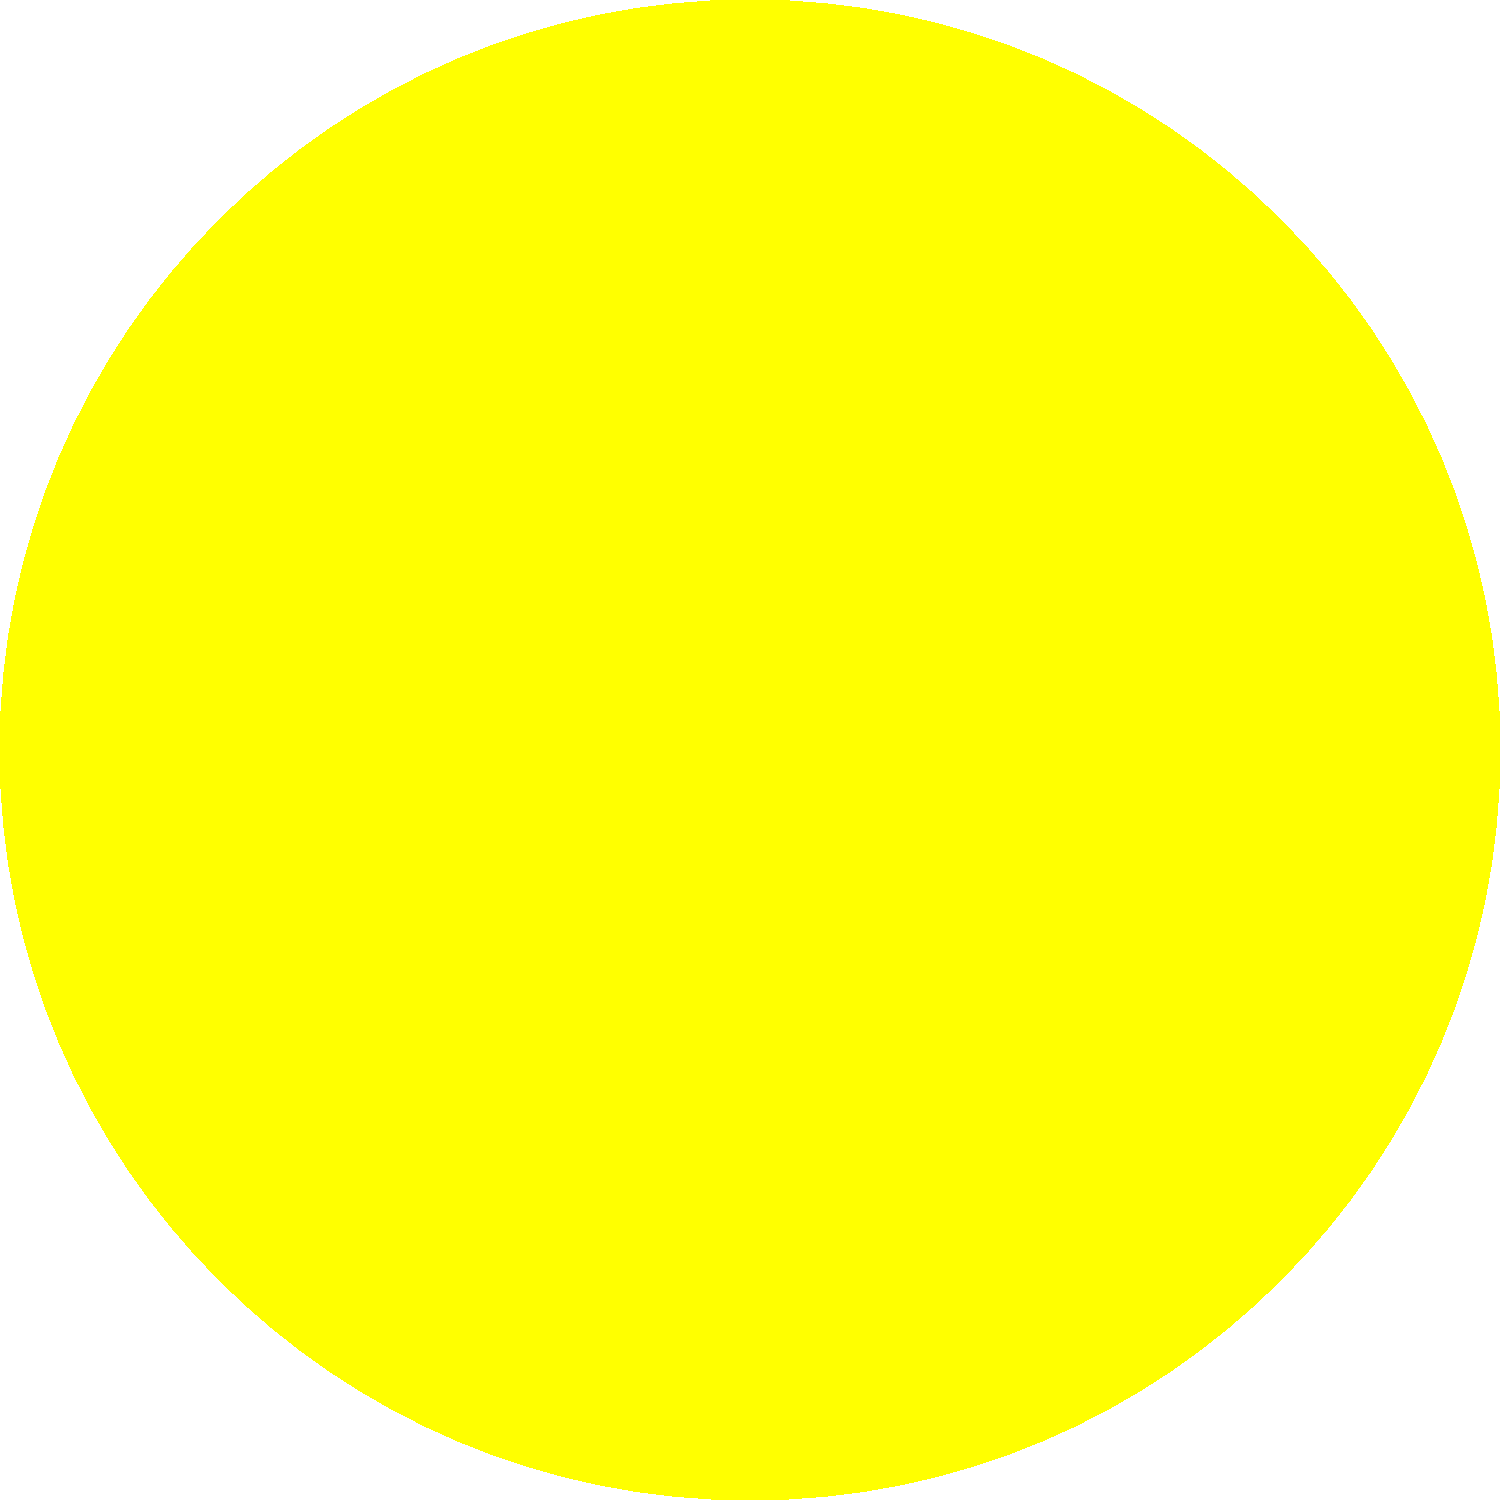As a software engineer with an interest in indie games, you're designing a space exploration game. You need to accurately represent the solar system's structure. Which planet has an orbit approximately twice the distance from the Sun compared to Earth's orbit? To answer this question, let's break down the information we have about the planets' orbits:

1. In our solar system, the planets are ordered from closest to farthest from the Sun as follows: Mercury, Venus, Earth, Mars, Jupiter, Saturn, Uranus, and Neptune.

2. The average distances of the planets from the Sun (in Astronomical Units, where 1 AU is the distance from Earth to the Sun) are approximately:
   - Mercury: 0.39 AU
   - Venus: 0.72 AU
   - Earth: 1.00 AU (by definition)
   - Mars: 1.52 AU
   - Jupiter: 5.20 AU
   - Saturn: 9.54 AU
   - Uranus: 19.19 AU
   - Neptune: 30.07 AU

3. We're looking for a planet with an orbit approximately twice the distance of Earth's orbit from the Sun.

4. Calculating twice Earth's distance:
   $2 \times 1.00 \text{ AU} = 2.00 \text{ AU}$

5. Comparing this to the list of planet distances, we can see that Mars is the closest match with 1.52 AU.

6. While Mars's orbit isn't exactly twice Earth's distance, it's the closest approximation among the planets in our solar system.

In the context of game development, this knowledge would be crucial for creating an accurate scale model of the solar system, ensuring that the relative distances between planets are represented correctly in your space exploration game.
Answer: Mars 